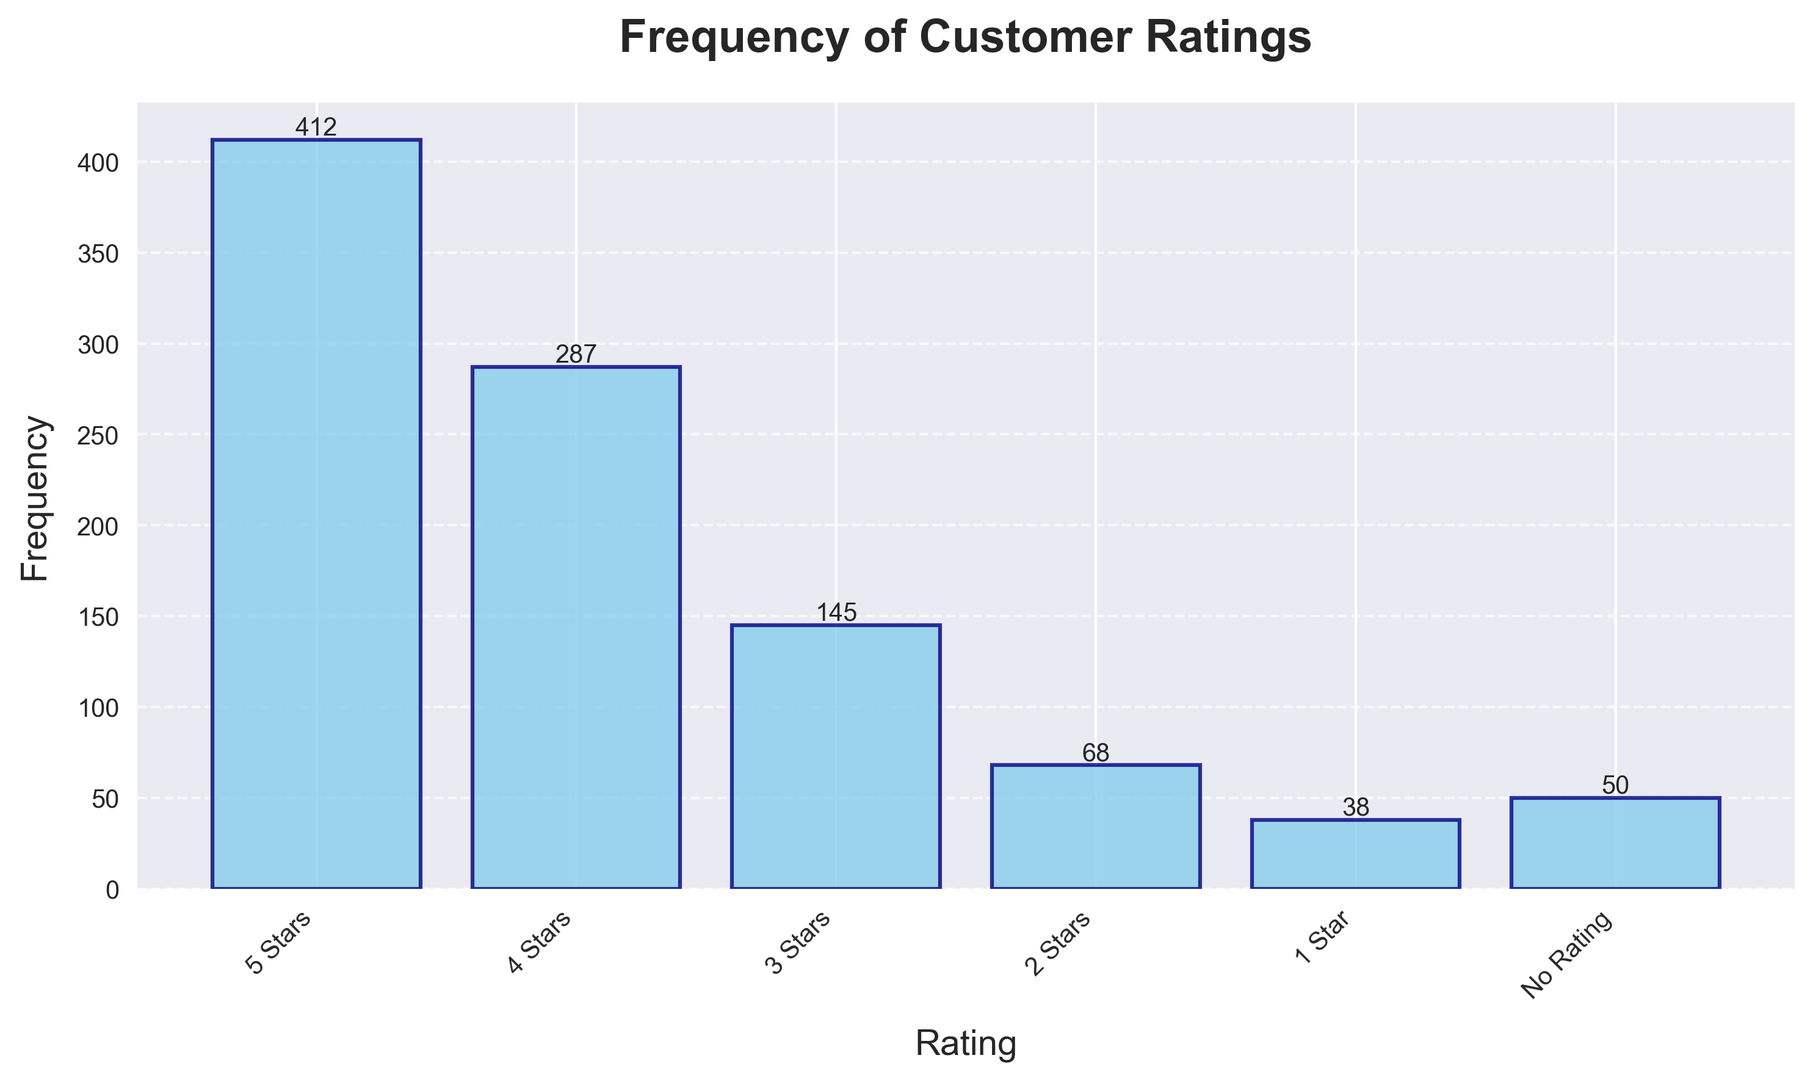What is the most common rating given to driver partners? By inspecting the height of the bars in the histogram, the 5 Stars rating has the highest frequency, indicating it is the most common.
Answer: 5 Stars Which rating has the least number of occurrences? Identify the shortest bar in the histogram which corresponds to the 1 Star rating with the frequency of 38.
Answer: 1 Star How many more 5 Stars ratings were received compared to 1 Star ratings? The 5 Stars rating has a frequency of 412 and the 1 Star rating has a frequency of 38. Subtract 38 from 412: 412 - 38 = 374.
Answer: 374 What is the total frequency of ratings that are 3 Stars or higher? Add the frequencies of 3 Stars, 4 Stars, and 5 Stars: 145 + 287 + 412 = 844.
Answer: 844 Is the number of 4 Stars ratings greater than the sum of 2 Stars and 1 Star ratings? Compare the 4 Stars rating (287) with the sum of 2 Stars (68) and 1 Star (38): 68 + 38 = 106. Since 287 > 106, the answer is yes.
Answer: Yes Which rating category's bar is visually represented with a height roughly half of the 5 Stars bar? Half of the 5 Stars frequency is 412/2 = 206. The 4 Stars bar, with a frequency of 287, is visually closest to half of 5 Stars in the histogram.
Answer: 4 Stars What percentage of the total ratings are 5 Stars? Calculate the total frequency of all ratings: 412 + 287 + 145 + 68 + 38 + 50 = 1000. The percentage of 5 Stars ratings is (412/1000) * 100 = 41.2%.
Answer: 41.2% What is the ratio of 4 Stars ratings to No Rating occurrences? Divide the frequency of 4 Stars (287) by No Rating (50): 287 / 50 = 5.74.
Answer: 5.74 How does the frequency of 3 Stars compare to the sum of 1 Star and No Rating occurrences? Sum the frequencies of 1 Star (38) and No Rating (50): 38 + 50 = 88. The frequency of 3 Stars is 145, which is greater than 88.
Answer: 3 Stars is greater If a driver partner receives a random rating, what is the probability it is 2 Stars? The total number of ratings is 1000. The probability of receiving a 2 Stars rating is the frequency of 2 Stars (68) divided by the total ratings: 68 / 1000 = 0.068 or 6.8%.
Answer: 6.8% 